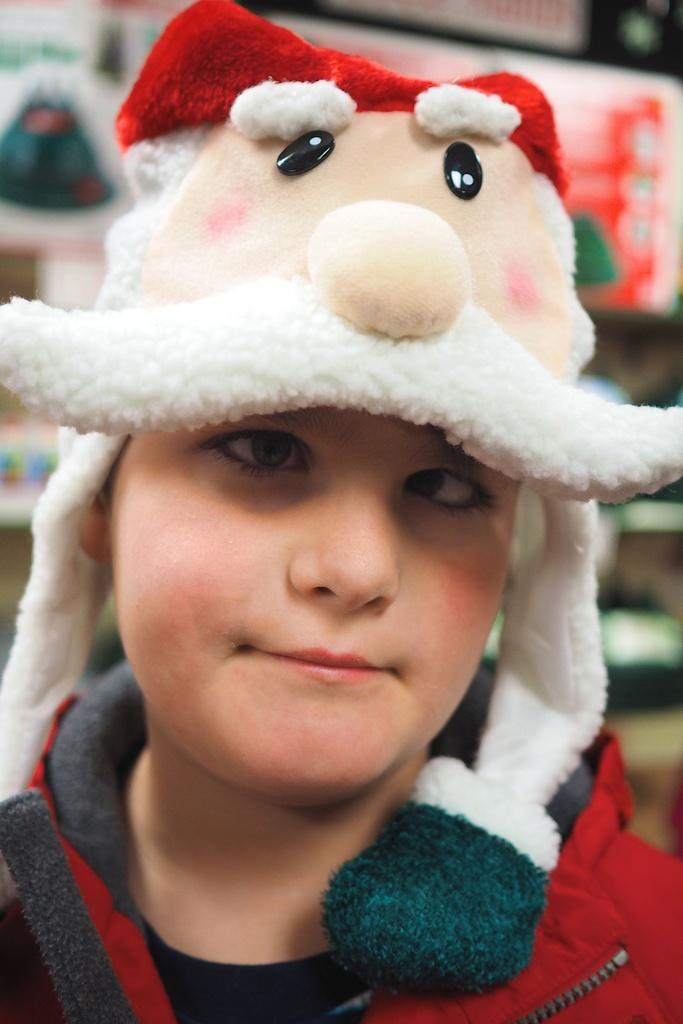What is the main subject of the image? There is a person in the image. What is the person wearing? The person is wearing a red jacket and a cap on their head. What is the person doing in the image? The person is looking at a picture. What can be seen in the background of the image? There are objects in a rack in the background of the image. How many corks are visible in the image? There are no corks present in the image. What type of account does the person have with the objects in the rack? There is no indication of any accounts or relationships between the person and the objects in the rack in the image. 